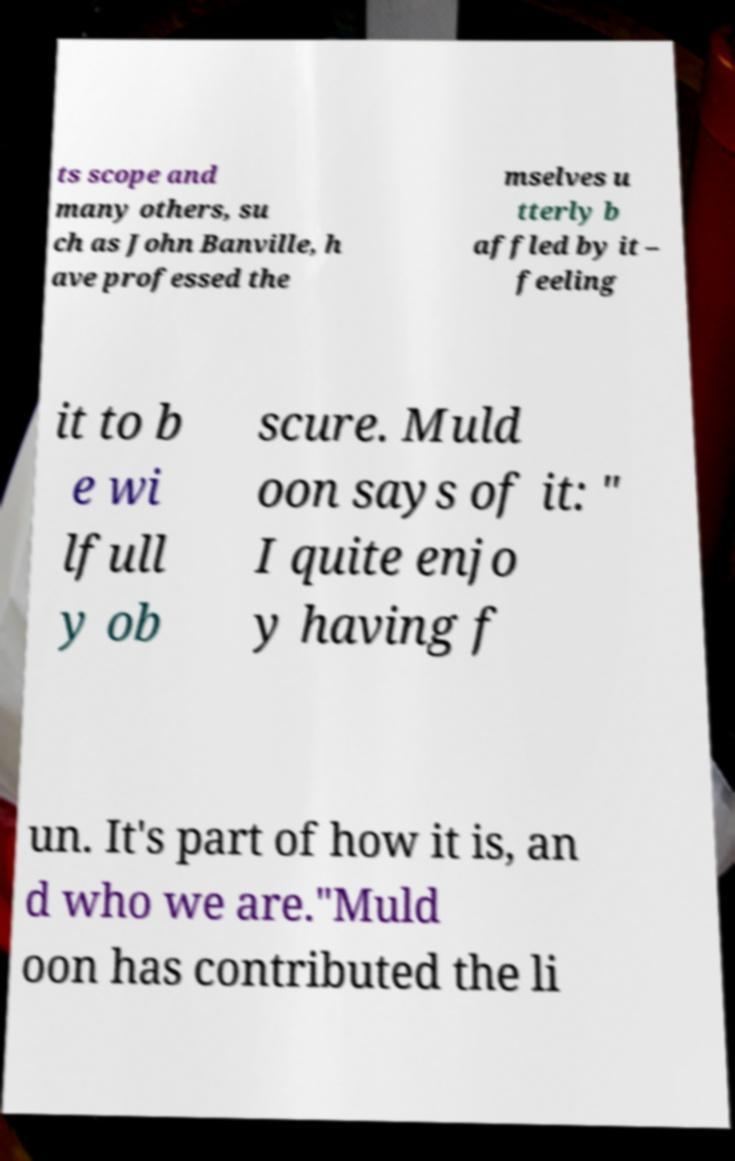Please read and relay the text visible in this image. What does it say? ts scope and many others, su ch as John Banville, h ave professed the mselves u tterly b affled by it – feeling it to b e wi lfull y ob scure. Muld oon says of it: " I quite enjo y having f un. It's part of how it is, an d who we are."Muld oon has contributed the li 